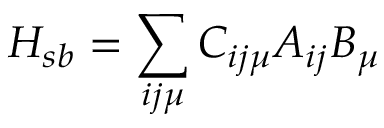Convert formula to latex. <formula><loc_0><loc_0><loc_500><loc_500>H _ { s b } = \sum _ { i j \mu } C _ { i j \mu } A _ { i j } B _ { \mu }</formula> 